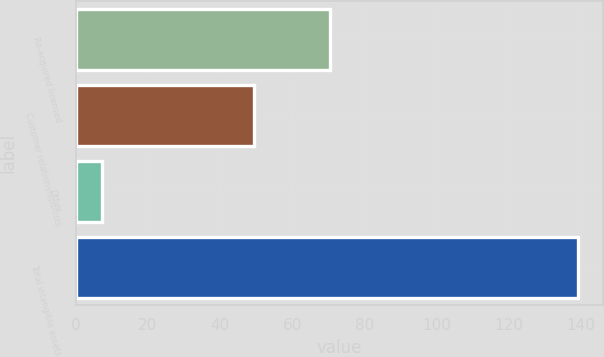Convert chart to OTSL. <chart><loc_0><loc_0><loc_500><loc_500><bar_chart><fcel>Re-acquired licensed<fcel>Customer relationships/lists<fcel>Other<fcel>Total intangible assets<nl><fcel>70.6<fcel>49.3<fcel>7.2<fcel>139.09<nl></chart> 